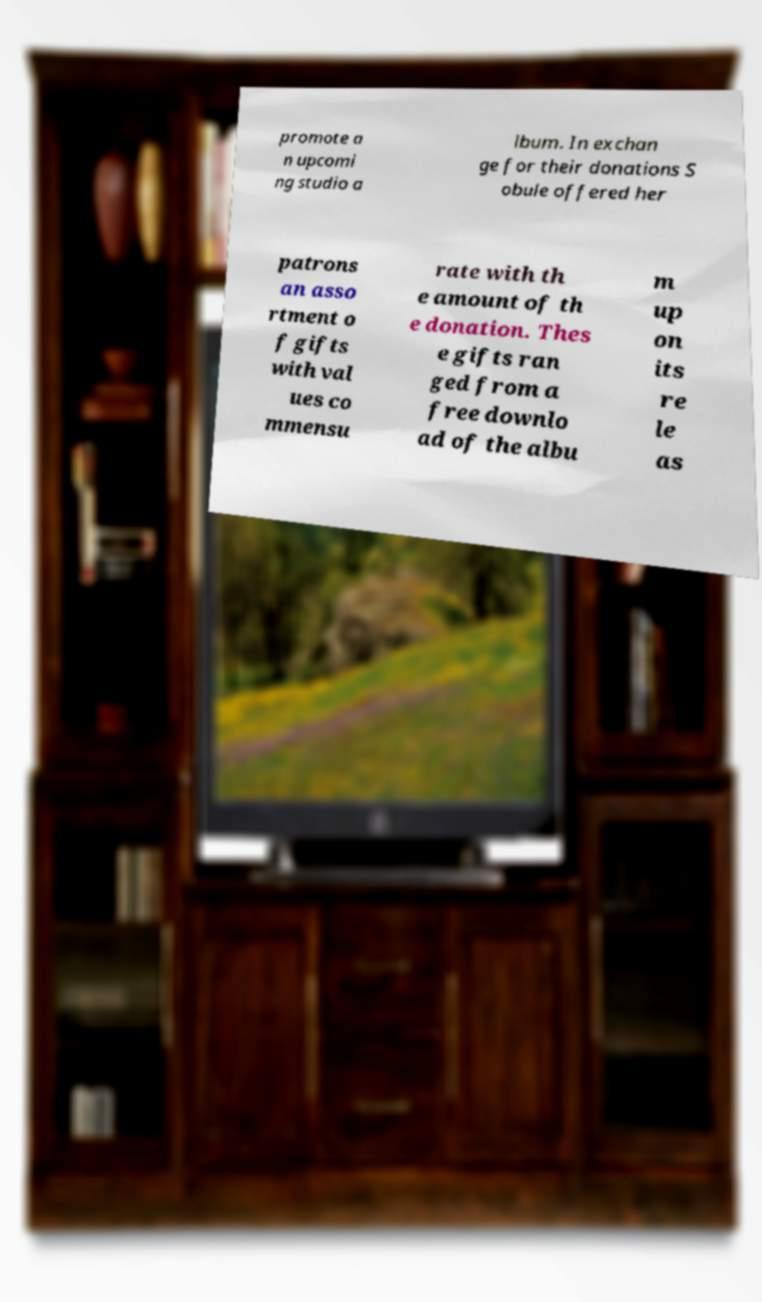Can you read and provide the text displayed in the image?This photo seems to have some interesting text. Can you extract and type it out for me? promote a n upcomi ng studio a lbum. In exchan ge for their donations S obule offered her patrons an asso rtment o f gifts with val ues co mmensu rate with th e amount of th e donation. Thes e gifts ran ged from a free downlo ad of the albu m up on its re le as 